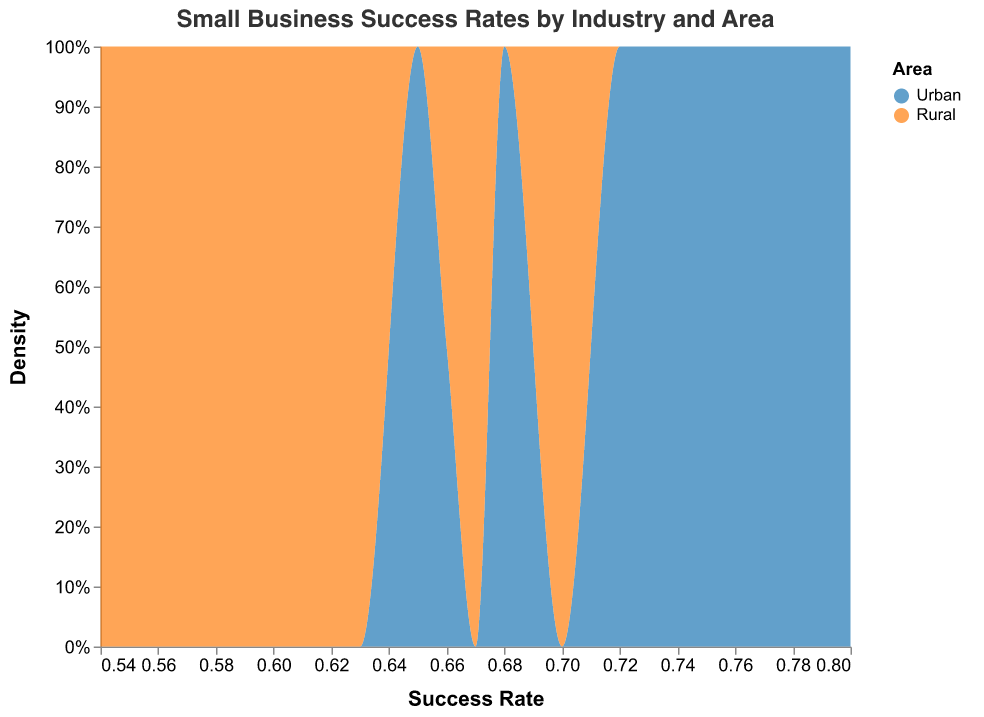What is the title of the density plot? The title of the density plot is clearly displayed at the top of the figure.
Answer: Small Business Success Rates by Industry and Area Which area has a higher density of small businesses with a success rate around 70%? By assessing the overlapping areas of the density plot, Urban areas have a higher density around the 70% success rate mark compared to Rural areas, indicated by a larger portion of the blue area.
Answer: Urban What is the density peak for urban areas? The density peak can be determined by identifying the highest point in the blue area of the density plot.
Answer: Around 80% Which industry has the lowest success rate in rural areas? By looking at the provided data points, the industry with the lowest success rate in Rural areas is identified as the one with the smallest success rate.
Answer: Hospitality How does the success rate for technology businesses compare between urban and rural areas? Comparing the success rates, Technology businesses in Urban areas have an 80% success rate, while in Rural areas, the success rate is 70%, showing Urban areas have a higher success rate.
Answer: Urban has a higher success rate What is the overall trend of success rates between urban and rural areas? Viewing the density plot, it shows that urban areas (blue) generally have higher success rates compared to rural areas (orange), with a shift towards the right.
Answer: Urban areas have higher success rates In which industry is the gap between urban and rural success rates biggest? By examining the differences between success rates for each industry, the gap is largest where the difference appears most significant in the data table.
Answer: Hospitality (0.65 - 0.54 = 0.11) Is the median success rate higher in urban or rural areas? The median success rate can be assessed visually by the center area of the distribution. The plot shows that the density is right-shifted for urban areas.
Answer: Urban areas How many industries have urban success rates above 75%? Count the number of success rates for different industries in urban areas above 75% from the data.
Answer: Four (Retail, Technology, Healthcare, Finance) Which area has a lower success rate for construction businesses, and what is it? From the data values, Construction businesses have different success rates for Urban and Rural, with Rural having a lower rate.
Answer: Rural, 0.55 